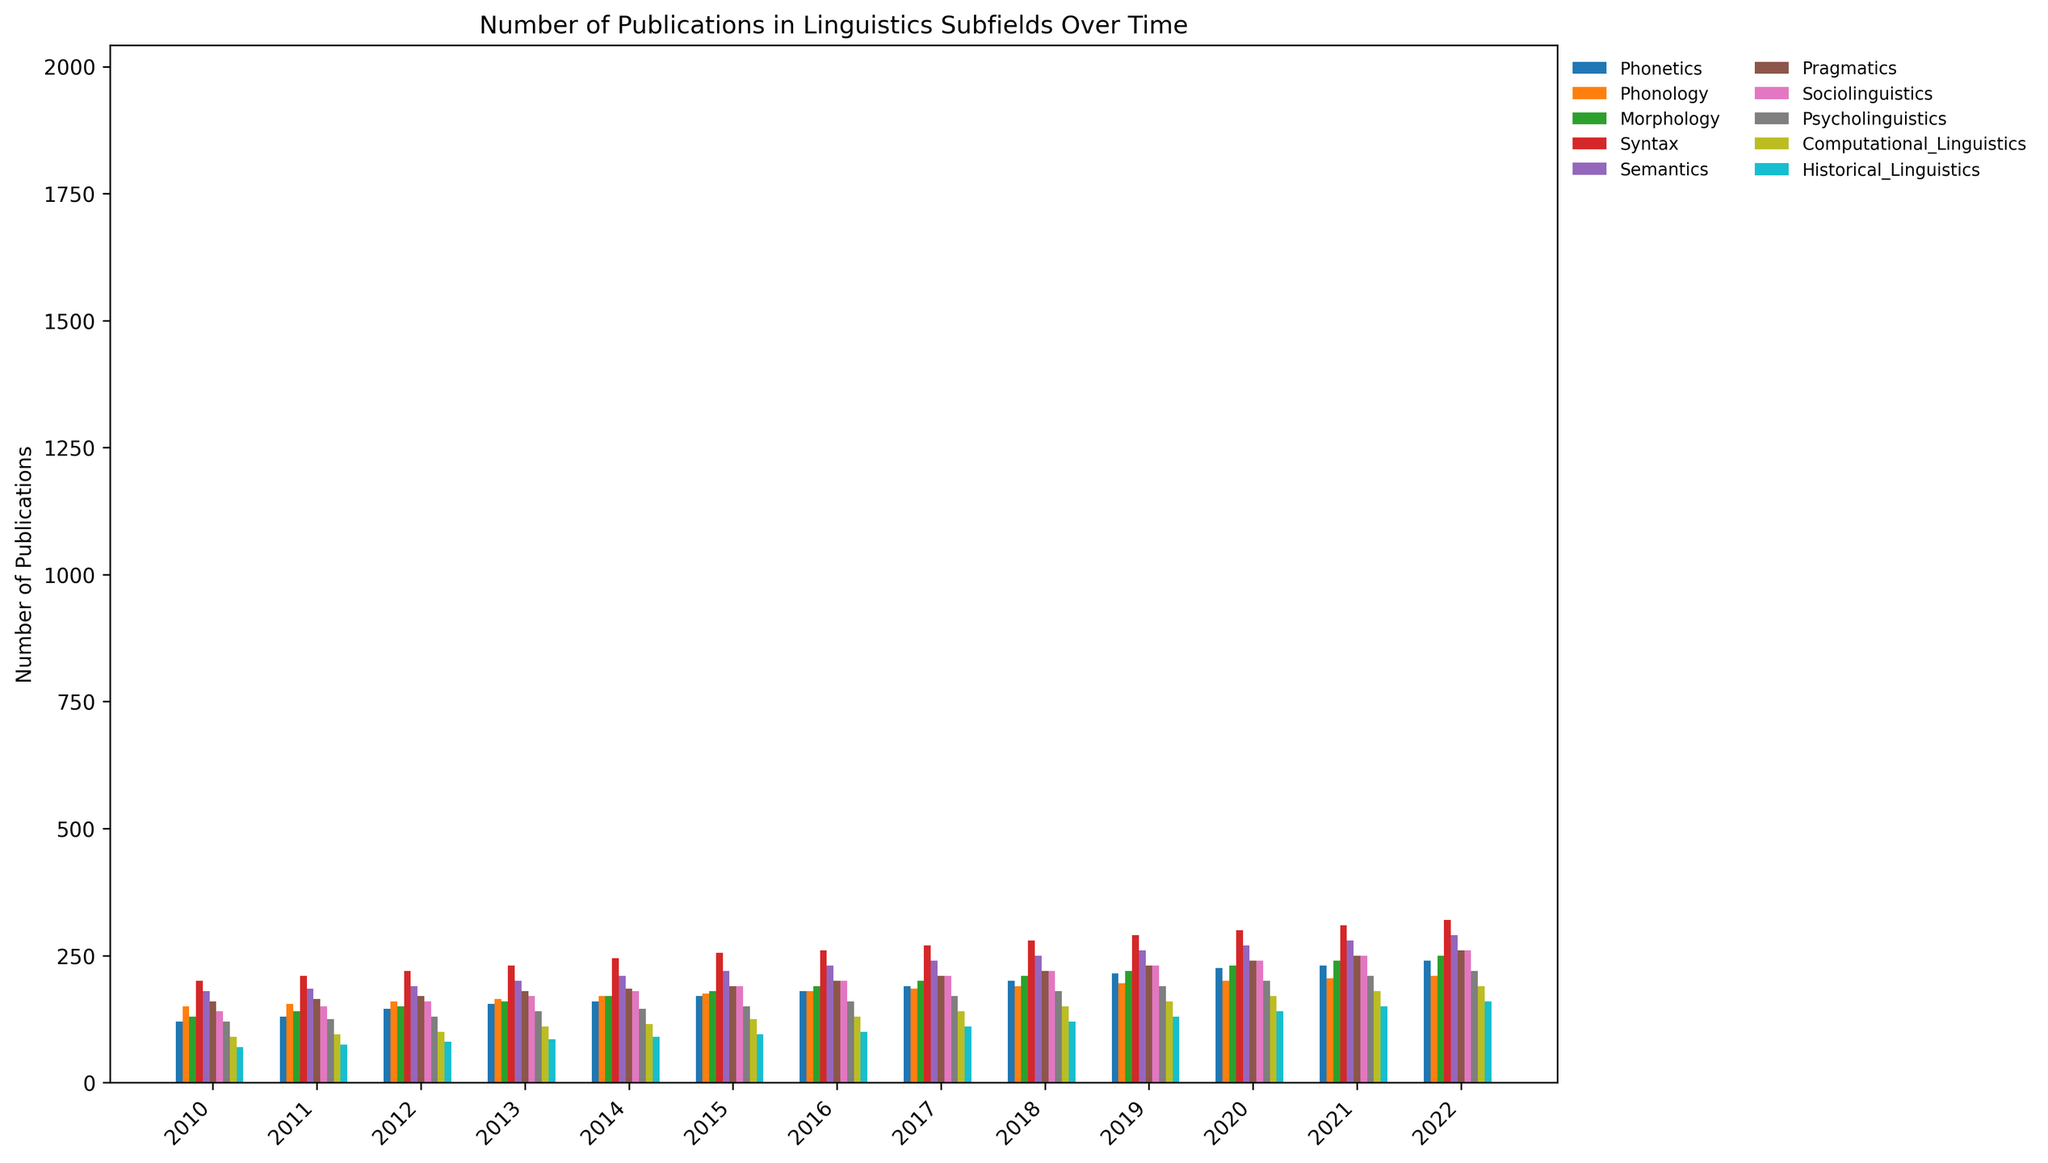What is the total number of publications in Syntax over the period 2010-2022? Sum up the values for Syntax from each year: 200 + 210 + 220 + 230 + 245 + 255 + 260 + 270 + 280 + 290 + 300 + 310 + 320 = 3390
Answer: 3390 Which subfield had the highest number of publications in 2022? Look at the data for the year 2022 and compare the number of publications across all subfields. Syntax has the highest value at 320.
Answer: Syntax How does the number of publications in 2015 compare between Pragmatics and Computational Linguistics? Compare the values in the 2015 column for Pragmatics (190) and Computational Linguistics (125). Pragmatics has more publications.
Answer: Pragmatics has more What is the mean number of publications per year for Semantics from 2010 to 2015? Sum the values for Semantics from 2010 to 2015: 180 + 185 + 190 + 200 + 210 + 220 = 1185. The number of years is 6, so the mean is 1185 / 6 = 197.5
Answer: 197.5 Between Phonetics and Sociolinguistics, which subfield shows a greater increase in publications from 2010 to 2022? Calculate the difference in publications for each subfield between 2010 and 2022. For Phonetics: 240 - 120 = 120. For Sociolinguistics: 260 - 140 = 120. Both subfields show an increase of 120 publications.
Answer: Both have equal increase In which year did Historical Linguistics first reach 100 publications? Look at the Historical Linguistics column to find the first instance of a value of 100 or more. This occurs in 2013 with a value of 85 reaching 100 in 2014.
Answer: 2014 How many more publications were there in Psycholinguistics than in Phonetics in 2020? Look at the 2020 values for Psycholinguistics (200) and Phonetics (225). Calculate the difference: 225 - 200 = 25
Answer: 25 What is the cumulative number of publications for the subfield Morphology across the years 2018 to 2020? Sum the values for Morphology from 2018, 2019, and 2020: 210 + 220 + 230 = 660
Answer: 660 Compare the growth trend in Syntax with Semantics over the entire period. Which subfield shows a steeper rise? Calculate the increase from 2010 to 2022 for both subfields. For Syntax: 320 - 200 = 120. For Semantics: 290 - 180 = 110. Syntax shows a greater increase.
Answer: Syntax Which year showed the highest number of overall publications across all subfields? Sum the values for each year and find the maximum:
2010: 1360,
2011: 1440,
2012: 1530,
2013: 1625,
2014: 1695,
2015: 1770,
2016: 1860,
2017: 1965,
2018: 2070,
2019: 2185,
2020: 2325,
2021: 2385,
2022: 2480. The highest number is in 2022 with 2480 publications.
Answer: 2022 